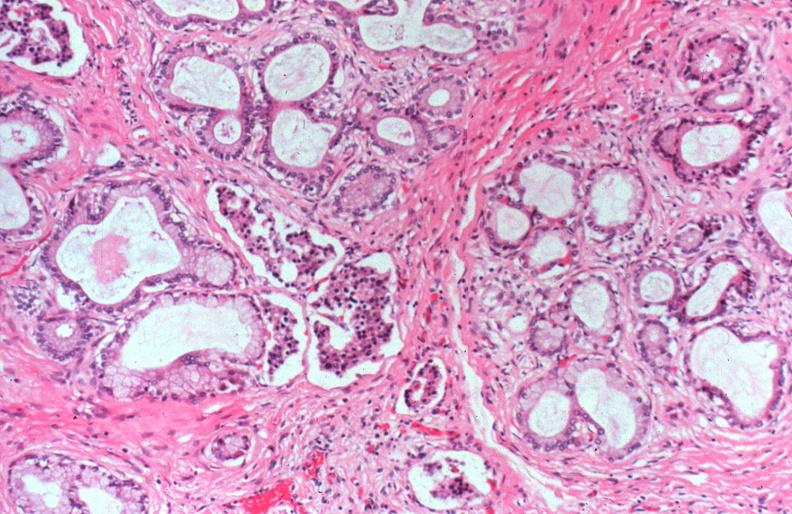s cerebrospinal fluid, smear showing gram negative cocci, neisseria meningitidis, gram stain present?
Answer the question using a single word or phrase. No 